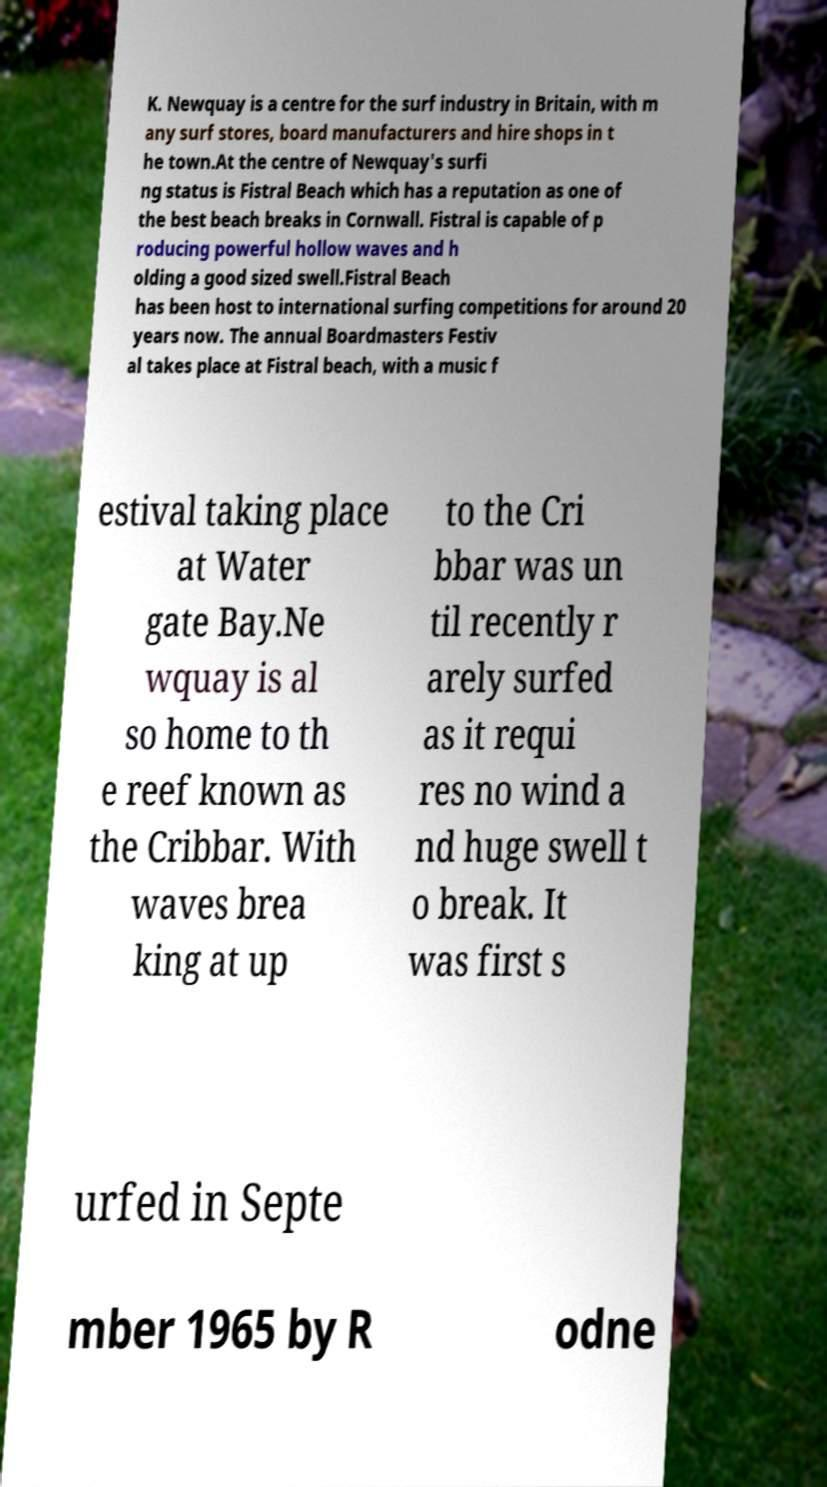Can you accurately transcribe the text from the provided image for me? K. Newquay is a centre for the surf industry in Britain, with m any surf stores, board manufacturers and hire shops in t he town.At the centre of Newquay's surfi ng status is Fistral Beach which has a reputation as one of the best beach breaks in Cornwall. Fistral is capable of p roducing powerful hollow waves and h olding a good sized swell.Fistral Beach has been host to international surfing competitions for around 20 years now. The annual Boardmasters Festiv al takes place at Fistral beach, with a music f estival taking place at Water gate Bay.Ne wquay is al so home to th e reef known as the Cribbar. With waves brea king at up to the Cri bbar was un til recently r arely surfed as it requi res no wind a nd huge swell t o break. It was first s urfed in Septe mber 1965 by R odne 